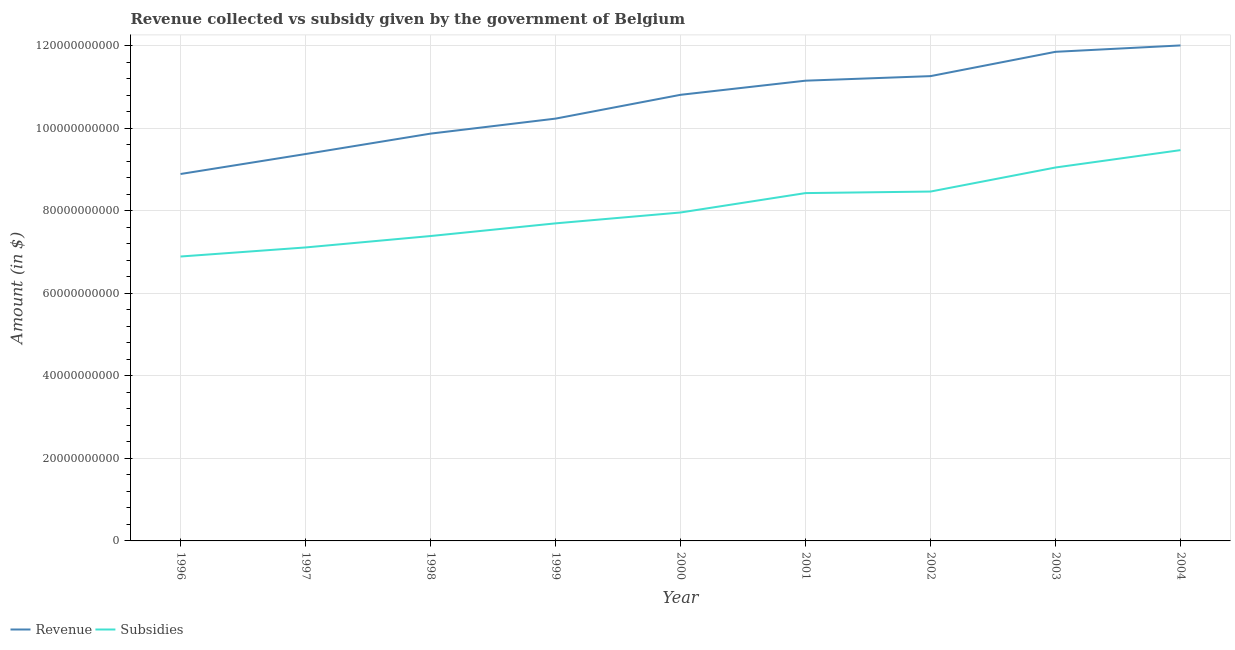Does the line corresponding to amount of subsidies given intersect with the line corresponding to amount of revenue collected?
Give a very brief answer. No. What is the amount of revenue collected in 2003?
Keep it short and to the point. 1.19e+11. Across all years, what is the maximum amount of revenue collected?
Your answer should be compact. 1.20e+11. Across all years, what is the minimum amount of subsidies given?
Give a very brief answer. 6.89e+1. In which year was the amount of subsidies given maximum?
Give a very brief answer. 2004. What is the total amount of revenue collected in the graph?
Your answer should be very brief. 9.55e+11. What is the difference between the amount of revenue collected in 1996 and that in 2003?
Make the answer very short. -2.96e+1. What is the difference between the amount of subsidies given in 1998 and the amount of revenue collected in 2002?
Ensure brevity in your answer.  -3.88e+1. What is the average amount of subsidies given per year?
Provide a succinct answer. 8.05e+1. In the year 2002, what is the difference between the amount of subsidies given and amount of revenue collected?
Offer a very short reply. -2.80e+1. In how many years, is the amount of revenue collected greater than 88000000000 $?
Give a very brief answer. 9. What is the ratio of the amount of subsidies given in 1996 to that in 1999?
Your answer should be very brief. 0.9. Is the amount of revenue collected in 2002 less than that in 2004?
Offer a terse response. Yes. What is the difference between the highest and the second highest amount of subsidies given?
Offer a very short reply. 4.21e+09. What is the difference between the highest and the lowest amount of subsidies given?
Offer a very short reply. 2.58e+1. In how many years, is the amount of revenue collected greater than the average amount of revenue collected taken over all years?
Provide a short and direct response. 5. How many years are there in the graph?
Provide a succinct answer. 9. What is the difference between two consecutive major ticks on the Y-axis?
Provide a succinct answer. 2.00e+1. Are the values on the major ticks of Y-axis written in scientific E-notation?
Provide a succinct answer. No. Does the graph contain any zero values?
Offer a terse response. No. Where does the legend appear in the graph?
Keep it short and to the point. Bottom left. How are the legend labels stacked?
Your answer should be very brief. Horizontal. What is the title of the graph?
Offer a very short reply. Revenue collected vs subsidy given by the government of Belgium. Does "Commercial service exports" appear as one of the legend labels in the graph?
Your answer should be very brief. No. What is the label or title of the X-axis?
Provide a short and direct response. Year. What is the label or title of the Y-axis?
Make the answer very short. Amount (in $). What is the Amount (in $) in Revenue in 1996?
Your response must be concise. 8.89e+1. What is the Amount (in $) in Subsidies in 1996?
Offer a very short reply. 6.89e+1. What is the Amount (in $) of Revenue in 1997?
Your answer should be very brief. 9.38e+1. What is the Amount (in $) of Subsidies in 1997?
Your response must be concise. 7.11e+1. What is the Amount (in $) in Revenue in 1998?
Keep it short and to the point. 9.87e+1. What is the Amount (in $) in Subsidies in 1998?
Provide a succinct answer. 7.39e+1. What is the Amount (in $) in Revenue in 1999?
Give a very brief answer. 1.02e+11. What is the Amount (in $) in Subsidies in 1999?
Give a very brief answer. 7.70e+1. What is the Amount (in $) in Revenue in 2000?
Your response must be concise. 1.08e+11. What is the Amount (in $) of Subsidies in 2000?
Offer a terse response. 7.96e+1. What is the Amount (in $) of Revenue in 2001?
Keep it short and to the point. 1.12e+11. What is the Amount (in $) of Subsidies in 2001?
Ensure brevity in your answer.  8.43e+1. What is the Amount (in $) of Revenue in 2002?
Your answer should be compact. 1.13e+11. What is the Amount (in $) in Subsidies in 2002?
Provide a succinct answer. 8.47e+1. What is the Amount (in $) of Revenue in 2003?
Offer a very short reply. 1.19e+11. What is the Amount (in $) in Subsidies in 2003?
Your response must be concise. 9.05e+1. What is the Amount (in $) of Revenue in 2004?
Your response must be concise. 1.20e+11. What is the Amount (in $) in Subsidies in 2004?
Give a very brief answer. 9.47e+1. Across all years, what is the maximum Amount (in $) of Revenue?
Offer a very short reply. 1.20e+11. Across all years, what is the maximum Amount (in $) of Subsidies?
Your response must be concise. 9.47e+1. Across all years, what is the minimum Amount (in $) in Revenue?
Keep it short and to the point. 8.89e+1. Across all years, what is the minimum Amount (in $) of Subsidies?
Your answer should be very brief. 6.89e+1. What is the total Amount (in $) in Revenue in the graph?
Give a very brief answer. 9.55e+11. What is the total Amount (in $) of Subsidies in the graph?
Provide a succinct answer. 7.25e+11. What is the difference between the Amount (in $) of Revenue in 1996 and that in 1997?
Offer a terse response. -4.84e+09. What is the difference between the Amount (in $) of Subsidies in 1996 and that in 1997?
Keep it short and to the point. -2.20e+09. What is the difference between the Amount (in $) of Revenue in 1996 and that in 1998?
Offer a very short reply. -9.78e+09. What is the difference between the Amount (in $) in Subsidies in 1996 and that in 1998?
Offer a very short reply. -4.97e+09. What is the difference between the Amount (in $) of Revenue in 1996 and that in 1999?
Provide a succinct answer. -1.34e+1. What is the difference between the Amount (in $) in Subsidies in 1996 and that in 1999?
Ensure brevity in your answer.  -8.04e+09. What is the difference between the Amount (in $) in Revenue in 1996 and that in 2000?
Offer a very short reply. -1.92e+1. What is the difference between the Amount (in $) in Subsidies in 1996 and that in 2000?
Give a very brief answer. -1.07e+1. What is the difference between the Amount (in $) of Revenue in 1996 and that in 2001?
Your answer should be very brief. -2.26e+1. What is the difference between the Amount (in $) in Subsidies in 1996 and that in 2001?
Offer a terse response. -1.54e+1. What is the difference between the Amount (in $) in Revenue in 1996 and that in 2002?
Offer a very short reply. -2.37e+1. What is the difference between the Amount (in $) in Subsidies in 1996 and that in 2002?
Make the answer very short. -1.57e+1. What is the difference between the Amount (in $) of Revenue in 1996 and that in 2003?
Your answer should be very brief. -2.96e+1. What is the difference between the Amount (in $) in Subsidies in 1996 and that in 2003?
Keep it short and to the point. -2.16e+1. What is the difference between the Amount (in $) in Revenue in 1996 and that in 2004?
Provide a short and direct response. -3.12e+1. What is the difference between the Amount (in $) in Subsidies in 1996 and that in 2004?
Provide a short and direct response. -2.58e+1. What is the difference between the Amount (in $) in Revenue in 1997 and that in 1998?
Ensure brevity in your answer.  -4.95e+09. What is the difference between the Amount (in $) of Subsidies in 1997 and that in 1998?
Provide a short and direct response. -2.77e+09. What is the difference between the Amount (in $) of Revenue in 1997 and that in 1999?
Make the answer very short. -8.58e+09. What is the difference between the Amount (in $) of Subsidies in 1997 and that in 1999?
Ensure brevity in your answer.  -5.84e+09. What is the difference between the Amount (in $) of Revenue in 1997 and that in 2000?
Ensure brevity in your answer.  -1.44e+1. What is the difference between the Amount (in $) in Subsidies in 1997 and that in 2000?
Offer a terse response. -8.47e+09. What is the difference between the Amount (in $) in Revenue in 1997 and that in 2001?
Ensure brevity in your answer.  -1.78e+1. What is the difference between the Amount (in $) of Subsidies in 1997 and that in 2001?
Keep it short and to the point. -1.32e+1. What is the difference between the Amount (in $) of Revenue in 1997 and that in 2002?
Make the answer very short. -1.89e+1. What is the difference between the Amount (in $) of Subsidies in 1997 and that in 2002?
Offer a terse response. -1.35e+1. What is the difference between the Amount (in $) in Revenue in 1997 and that in 2003?
Your answer should be compact. -2.48e+1. What is the difference between the Amount (in $) in Subsidies in 1997 and that in 2003?
Provide a short and direct response. -1.94e+1. What is the difference between the Amount (in $) in Revenue in 1997 and that in 2004?
Provide a short and direct response. -2.63e+1. What is the difference between the Amount (in $) of Subsidies in 1997 and that in 2004?
Provide a succinct answer. -2.36e+1. What is the difference between the Amount (in $) in Revenue in 1998 and that in 1999?
Your response must be concise. -3.64e+09. What is the difference between the Amount (in $) of Subsidies in 1998 and that in 1999?
Keep it short and to the point. -3.07e+09. What is the difference between the Amount (in $) of Revenue in 1998 and that in 2000?
Offer a terse response. -9.41e+09. What is the difference between the Amount (in $) in Subsidies in 1998 and that in 2000?
Provide a succinct answer. -5.70e+09. What is the difference between the Amount (in $) of Revenue in 1998 and that in 2001?
Ensure brevity in your answer.  -1.28e+1. What is the difference between the Amount (in $) of Subsidies in 1998 and that in 2001?
Provide a succinct answer. -1.04e+1. What is the difference between the Amount (in $) of Revenue in 1998 and that in 2002?
Offer a terse response. -1.39e+1. What is the difference between the Amount (in $) in Subsidies in 1998 and that in 2002?
Give a very brief answer. -1.08e+1. What is the difference between the Amount (in $) of Revenue in 1998 and that in 2003?
Keep it short and to the point. -1.98e+1. What is the difference between the Amount (in $) of Subsidies in 1998 and that in 2003?
Offer a very short reply. -1.66e+1. What is the difference between the Amount (in $) of Revenue in 1998 and that in 2004?
Your response must be concise. -2.14e+1. What is the difference between the Amount (in $) of Subsidies in 1998 and that in 2004?
Your response must be concise. -2.08e+1. What is the difference between the Amount (in $) of Revenue in 1999 and that in 2000?
Offer a very short reply. -5.77e+09. What is the difference between the Amount (in $) of Subsidies in 1999 and that in 2000?
Ensure brevity in your answer.  -2.63e+09. What is the difference between the Amount (in $) in Revenue in 1999 and that in 2001?
Offer a very short reply. -9.20e+09. What is the difference between the Amount (in $) in Subsidies in 1999 and that in 2001?
Provide a short and direct response. -7.34e+09. What is the difference between the Amount (in $) of Revenue in 1999 and that in 2002?
Provide a succinct answer. -1.03e+1. What is the difference between the Amount (in $) in Subsidies in 1999 and that in 2002?
Offer a terse response. -7.71e+09. What is the difference between the Amount (in $) of Revenue in 1999 and that in 2003?
Your answer should be very brief. -1.62e+1. What is the difference between the Amount (in $) of Subsidies in 1999 and that in 2003?
Ensure brevity in your answer.  -1.35e+1. What is the difference between the Amount (in $) of Revenue in 1999 and that in 2004?
Make the answer very short. -1.77e+1. What is the difference between the Amount (in $) of Subsidies in 1999 and that in 2004?
Keep it short and to the point. -1.77e+1. What is the difference between the Amount (in $) of Revenue in 2000 and that in 2001?
Make the answer very short. -3.43e+09. What is the difference between the Amount (in $) in Subsidies in 2000 and that in 2001?
Your response must be concise. -4.70e+09. What is the difference between the Amount (in $) of Revenue in 2000 and that in 2002?
Your answer should be very brief. -4.53e+09. What is the difference between the Amount (in $) of Subsidies in 2000 and that in 2002?
Offer a terse response. -5.08e+09. What is the difference between the Amount (in $) of Revenue in 2000 and that in 2003?
Make the answer very short. -1.04e+1. What is the difference between the Amount (in $) in Subsidies in 2000 and that in 2003?
Provide a short and direct response. -1.09e+1. What is the difference between the Amount (in $) of Revenue in 2000 and that in 2004?
Keep it short and to the point. -1.20e+1. What is the difference between the Amount (in $) of Subsidies in 2000 and that in 2004?
Give a very brief answer. -1.51e+1. What is the difference between the Amount (in $) in Revenue in 2001 and that in 2002?
Give a very brief answer. -1.10e+09. What is the difference between the Amount (in $) in Subsidies in 2001 and that in 2002?
Ensure brevity in your answer.  -3.72e+08. What is the difference between the Amount (in $) in Revenue in 2001 and that in 2003?
Ensure brevity in your answer.  -7.00e+09. What is the difference between the Amount (in $) in Subsidies in 2001 and that in 2003?
Give a very brief answer. -6.20e+09. What is the difference between the Amount (in $) of Revenue in 2001 and that in 2004?
Your response must be concise. -8.54e+09. What is the difference between the Amount (in $) of Subsidies in 2001 and that in 2004?
Ensure brevity in your answer.  -1.04e+1. What is the difference between the Amount (in $) of Revenue in 2002 and that in 2003?
Your answer should be compact. -5.89e+09. What is the difference between the Amount (in $) of Subsidies in 2002 and that in 2003?
Offer a very short reply. -5.83e+09. What is the difference between the Amount (in $) in Revenue in 2002 and that in 2004?
Make the answer very short. -7.44e+09. What is the difference between the Amount (in $) in Subsidies in 2002 and that in 2004?
Your response must be concise. -1.00e+1. What is the difference between the Amount (in $) of Revenue in 2003 and that in 2004?
Offer a very short reply. -1.55e+09. What is the difference between the Amount (in $) in Subsidies in 2003 and that in 2004?
Your answer should be compact. -4.21e+09. What is the difference between the Amount (in $) in Revenue in 1996 and the Amount (in $) in Subsidies in 1997?
Provide a short and direct response. 1.78e+1. What is the difference between the Amount (in $) of Revenue in 1996 and the Amount (in $) of Subsidies in 1998?
Your response must be concise. 1.50e+1. What is the difference between the Amount (in $) in Revenue in 1996 and the Amount (in $) in Subsidies in 1999?
Provide a short and direct response. 1.20e+1. What is the difference between the Amount (in $) in Revenue in 1996 and the Amount (in $) in Subsidies in 2000?
Provide a short and direct response. 9.33e+09. What is the difference between the Amount (in $) of Revenue in 1996 and the Amount (in $) of Subsidies in 2001?
Your answer should be very brief. 4.63e+09. What is the difference between the Amount (in $) of Revenue in 1996 and the Amount (in $) of Subsidies in 2002?
Ensure brevity in your answer.  4.25e+09. What is the difference between the Amount (in $) of Revenue in 1996 and the Amount (in $) of Subsidies in 2003?
Your answer should be compact. -1.58e+09. What is the difference between the Amount (in $) in Revenue in 1996 and the Amount (in $) in Subsidies in 2004?
Your answer should be very brief. -5.79e+09. What is the difference between the Amount (in $) of Revenue in 1997 and the Amount (in $) of Subsidies in 1998?
Your response must be concise. 1.99e+1. What is the difference between the Amount (in $) in Revenue in 1997 and the Amount (in $) in Subsidies in 1999?
Your answer should be very brief. 1.68e+1. What is the difference between the Amount (in $) in Revenue in 1997 and the Amount (in $) in Subsidies in 2000?
Give a very brief answer. 1.42e+1. What is the difference between the Amount (in $) of Revenue in 1997 and the Amount (in $) of Subsidies in 2001?
Offer a very short reply. 9.46e+09. What is the difference between the Amount (in $) in Revenue in 1997 and the Amount (in $) in Subsidies in 2002?
Offer a terse response. 9.09e+09. What is the difference between the Amount (in $) of Revenue in 1997 and the Amount (in $) of Subsidies in 2003?
Ensure brevity in your answer.  3.26e+09. What is the difference between the Amount (in $) in Revenue in 1997 and the Amount (in $) in Subsidies in 2004?
Provide a short and direct response. -9.47e+08. What is the difference between the Amount (in $) in Revenue in 1998 and the Amount (in $) in Subsidies in 1999?
Keep it short and to the point. 2.17e+1. What is the difference between the Amount (in $) of Revenue in 1998 and the Amount (in $) of Subsidies in 2000?
Your answer should be very brief. 1.91e+1. What is the difference between the Amount (in $) of Revenue in 1998 and the Amount (in $) of Subsidies in 2001?
Your response must be concise. 1.44e+1. What is the difference between the Amount (in $) in Revenue in 1998 and the Amount (in $) in Subsidies in 2002?
Your answer should be very brief. 1.40e+1. What is the difference between the Amount (in $) of Revenue in 1998 and the Amount (in $) of Subsidies in 2003?
Give a very brief answer. 8.21e+09. What is the difference between the Amount (in $) of Revenue in 1998 and the Amount (in $) of Subsidies in 2004?
Provide a short and direct response. 4.00e+09. What is the difference between the Amount (in $) in Revenue in 1999 and the Amount (in $) in Subsidies in 2000?
Your answer should be very brief. 2.28e+1. What is the difference between the Amount (in $) in Revenue in 1999 and the Amount (in $) in Subsidies in 2001?
Your response must be concise. 1.80e+1. What is the difference between the Amount (in $) of Revenue in 1999 and the Amount (in $) of Subsidies in 2002?
Your answer should be compact. 1.77e+1. What is the difference between the Amount (in $) in Revenue in 1999 and the Amount (in $) in Subsidies in 2003?
Keep it short and to the point. 1.18e+1. What is the difference between the Amount (in $) in Revenue in 1999 and the Amount (in $) in Subsidies in 2004?
Ensure brevity in your answer.  7.64e+09. What is the difference between the Amount (in $) in Revenue in 2000 and the Amount (in $) in Subsidies in 2001?
Provide a succinct answer. 2.38e+1. What is the difference between the Amount (in $) of Revenue in 2000 and the Amount (in $) of Subsidies in 2002?
Keep it short and to the point. 2.34e+1. What is the difference between the Amount (in $) in Revenue in 2000 and the Amount (in $) in Subsidies in 2003?
Your answer should be compact. 1.76e+1. What is the difference between the Amount (in $) in Revenue in 2000 and the Amount (in $) in Subsidies in 2004?
Your answer should be compact. 1.34e+1. What is the difference between the Amount (in $) of Revenue in 2001 and the Amount (in $) of Subsidies in 2002?
Offer a very short reply. 2.69e+1. What is the difference between the Amount (in $) in Revenue in 2001 and the Amount (in $) in Subsidies in 2003?
Keep it short and to the point. 2.10e+1. What is the difference between the Amount (in $) of Revenue in 2001 and the Amount (in $) of Subsidies in 2004?
Provide a short and direct response. 1.68e+1. What is the difference between the Amount (in $) in Revenue in 2002 and the Amount (in $) in Subsidies in 2003?
Your answer should be compact. 2.21e+1. What is the difference between the Amount (in $) of Revenue in 2002 and the Amount (in $) of Subsidies in 2004?
Offer a terse response. 1.79e+1. What is the difference between the Amount (in $) of Revenue in 2003 and the Amount (in $) of Subsidies in 2004?
Offer a very short reply. 2.38e+1. What is the average Amount (in $) in Revenue per year?
Keep it short and to the point. 1.06e+11. What is the average Amount (in $) of Subsidies per year?
Your answer should be compact. 8.05e+1. In the year 1996, what is the difference between the Amount (in $) in Revenue and Amount (in $) in Subsidies?
Your response must be concise. 2.00e+1. In the year 1997, what is the difference between the Amount (in $) in Revenue and Amount (in $) in Subsidies?
Make the answer very short. 2.26e+1. In the year 1998, what is the difference between the Amount (in $) in Revenue and Amount (in $) in Subsidies?
Offer a very short reply. 2.48e+1. In the year 1999, what is the difference between the Amount (in $) in Revenue and Amount (in $) in Subsidies?
Offer a terse response. 2.54e+1. In the year 2000, what is the difference between the Amount (in $) of Revenue and Amount (in $) of Subsidies?
Make the answer very short. 2.85e+1. In the year 2001, what is the difference between the Amount (in $) in Revenue and Amount (in $) in Subsidies?
Make the answer very short. 2.72e+1. In the year 2002, what is the difference between the Amount (in $) of Revenue and Amount (in $) of Subsidies?
Ensure brevity in your answer.  2.80e+1. In the year 2003, what is the difference between the Amount (in $) in Revenue and Amount (in $) in Subsidies?
Offer a very short reply. 2.80e+1. In the year 2004, what is the difference between the Amount (in $) of Revenue and Amount (in $) of Subsidies?
Keep it short and to the point. 2.54e+1. What is the ratio of the Amount (in $) in Revenue in 1996 to that in 1997?
Give a very brief answer. 0.95. What is the ratio of the Amount (in $) in Subsidies in 1996 to that in 1997?
Ensure brevity in your answer.  0.97. What is the ratio of the Amount (in $) in Revenue in 1996 to that in 1998?
Offer a terse response. 0.9. What is the ratio of the Amount (in $) of Subsidies in 1996 to that in 1998?
Offer a very short reply. 0.93. What is the ratio of the Amount (in $) of Revenue in 1996 to that in 1999?
Keep it short and to the point. 0.87. What is the ratio of the Amount (in $) of Subsidies in 1996 to that in 1999?
Keep it short and to the point. 0.9. What is the ratio of the Amount (in $) in Revenue in 1996 to that in 2000?
Make the answer very short. 0.82. What is the ratio of the Amount (in $) in Subsidies in 1996 to that in 2000?
Provide a short and direct response. 0.87. What is the ratio of the Amount (in $) in Revenue in 1996 to that in 2001?
Keep it short and to the point. 0.8. What is the ratio of the Amount (in $) of Subsidies in 1996 to that in 2001?
Your response must be concise. 0.82. What is the ratio of the Amount (in $) of Revenue in 1996 to that in 2002?
Keep it short and to the point. 0.79. What is the ratio of the Amount (in $) in Subsidies in 1996 to that in 2002?
Provide a short and direct response. 0.81. What is the ratio of the Amount (in $) in Revenue in 1996 to that in 2003?
Give a very brief answer. 0.75. What is the ratio of the Amount (in $) of Subsidies in 1996 to that in 2003?
Offer a very short reply. 0.76. What is the ratio of the Amount (in $) of Revenue in 1996 to that in 2004?
Make the answer very short. 0.74. What is the ratio of the Amount (in $) of Subsidies in 1996 to that in 2004?
Your answer should be compact. 0.73. What is the ratio of the Amount (in $) in Revenue in 1997 to that in 1998?
Provide a succinct answer. 0.95. What is the ratio of the Amount (in $) of Subsidies in 1997 to that in 1998?
Offer a very short reply. 0.96. What is the ratio of the Amount (in $) of Revenue in 1997 to that in 1999?
Your answer should be very brief. 0.92. What is the ratio of the Amount (in $) of Subsidies in 1997 to that in 1999?
Give a very brief answer. 0.92. What is the ratio of the Amount (in $) of Revenue in 1997 to that in 2000?
Provide a succinct answer. 0.87. What is the ratio of the Amount (in $) in Subsidies in 1997 to that in 2000?
Offer a very short reply. 0.89. What is the ratio of the Amount (in $) of Revenue in 1997 to that in 2001?
Provide a short and direct response. 0.84. What is the ratio of the Amount (in $) of Subsidies in 1997 to that in 2001?
Your answer should be compact. 0.84. What is the ratio of the Amount (in $) of Revenue in 1997 to that in 2002?
Your response must be concise. 0.83. What is the ratio of the Amount (in $) in Subsidies in 1997 to that in 2002?
Ensure brevity in your answer.  0.84. What is the ratio of the Amount (in $) of Revenue in 1997 to that in 2003?
Give a very brief answer. 0.79. What is the ratio of the Amount (in $) of Subsidies in 1997 to that in 2003?
Offer a very short reply. 0.79. What is the ratio of the Amount (in $) in Revenue in 1997 to that in 2004?
Keep it short and to the point. 0.78. What is the ratio of the Amount (in $) of Subsidies in 1997 to that in 2004?
Your response must be concise. 0.75. What is the ratio of the Amount (in $) of Revenue in 1998 to that in 1999?
Your answer should be very brief. 0.96. What is the ratio of the Amount (in $) of Subsidies in 1998 to that in 1999?
Your answer should be very brief. 0.96. What is the ratio of the Amount (in $) in Revenue in 1998 to that in 2000?
Offer a very short reply. 0.91. What is the ratio of the Amount (in $) in Subsidies in 1998 to that in 2000?
Ensure brevity in your answer.  0.93. What is the ratio of the Amount (in $) in Revenue in 1998 to that in 2001?
Your answer should be very brief. 0.89. What is the ratio of the Amount (in $) of Subsidies in 1998 to that in 2001?
Make the answer very short. 0.88. What is the ratio of the Amount (in $) of Revenue in 1998 to that in 2002?
Make the answer very short. 0.88. What is the ratio of the Amount (in $) of Subsidies in 1998 to that in 2002?
Ensure brevity in your answer.  0.87. What is the ratio of the Amount (in $) in Revenue in 1998 to that in 2003?
Offer a terse response. 0.83. What is the ratio of the Amount (in $) in Subsidies in 1998 to that in 2003?
Your answer should be very brief. 0.82. What is the ratio of the Amount (in $) in Revenue in 1998 to that in 2004?
Your answer should be compact. 0.82. What is the ratio of the Amount (in $) in Subsidies in 1998 to that in 2004?
Offer a terse response. 0.78. What is the ratio of the Amount (in $) of Revenue in 1999 to that in 2000?
Provide a succinct answer. 0.95. What is the ratio of the Amount (in $) of Subsidies in 1999 to that in 2000?
Provide a short and direct response. 0.97. What is the ratio of the Amount (in $) in Revenue in 1999 to that in 2001?
Give a very brief answer. 0.92. What is the ratio of the Amount (in $) of Subsidies in 1999 to that in 2001?
Make the answer very short. 0.91. What is the ratio of the Amount (in $) in Revenue in 1999 to that in 2002?
Offer a terse response. 0.91. What is the ratio of the Amount (in $) of Subsidies in 1999 to that in 2002?
Provide a succinct answer. 0.91. What is the ratio of the Amount (in $) in Revenue in 1999 to that in 2003?
Provide a short and direct response. 0.86. What is the ratio of the Amount (in $) in Subsidies in 1999 to that in 2003?
Offer a terse response. 0.85. What is the ratio of the Amount (in $) in Revenue in 1999 to that in 2004?
Offer a terse response. 0.85. What is the ratio of the Amount (in $) of Subsidies in 1999 to that in 2004?
Provide a short and direct response. 0.81. What is the ratio of the Amount (in $) of Revenue in 2000 to that in 2001?
Give a very brief answer. 0.97. What is the ratio of the Amount (in $) in Subsidies in 2000 to that in 2001?
Keep it short and to the point. 0.94. What is the ratio of the Amount (in $) in Revenue in 2000 to that in 2002?
Your answer should be compact. 0.96. What is the ratio of the Amount (in $) in Subsidies in 2000 to that in 2002?
Make the answer very short. 0.94. What is the ratio of the Amount (in $) in Revenue in 2000 to that in 2003?
Ensure brevity in your answer.  0.91. What is the ratio of the Amount (in $) in Subsidies in 2000 to that in 2003?
Your response must be concise. 0.88. What is the ratio of the Amount (in $) of Revenue in 2000 to that in 2004?
Keep it short and to the point. 0.9. What is the ratio of the Amount (in $) in Subsidies in 2000 to that in 2004?
Provide a succinct answer. 0.84. What is the ratio of the Amount (in $) of Revenue in 2001 to that in 2002?
Your response must be concise. 0.99. What is the ratio of the Amount (in $) of Revenue in 2001 to that in 2003?
Give a very brief answer. 0.94. What is the ratio of the Amount (in $) of Subsidies in 2001 to that in 2003?
Your answer should be very brief. 0.93. What is the ratio of the Amount (in $) of Revenue in 2001 to that in 2004?
Provide a short and direct response. 0.93. What is the ratio of the Amount (in $) of Subsidies in 2001 to that in 2004?
Your answer should be compact. 0.89. What is the ratio of the Amount (in $) in Revenue in 2002 to that in 2003?
Ensure brevity in your answer.  0.95. What is the ratio of the Amount (in $) in Subsidies in 2002 to that in 2003?
Provide a short and direct response. 0.94. What is the ratio of the Amount (in $) in Revenue in 2002 to that in 2004?
Offer a terse response. 0.94. What is the ratio of the Amount (in $) of Subsidies in 2002 to that in 2004?
Your answer should be compact. 0.89. What is the ratio of the Amount (in $) of Revenue in 2003 to that in 2004?
Offer a very short reply. 0.99. What is the ratio of the Amount (in $) in Subsidies in 2003 to that in 2004?
Provide a short and direct response. 0.96. What is the difference between the highest and the second highest Amount (in $) of Revenue?
Offer a very short reply. 1.55e+09. What is the difference between the highest and the second highest Amount (in $) of Subsidies?
Your answer should be very brief. 4.21e+09. What is the difference between the highest and the lowest Amount (in $) in Revenue?
Keep it short and to the point. 3.12e+1. What is the difference between the highest and the lowest Amount (in $) of Subsidies?
Your answer should be very brief. 2.58e+1. 